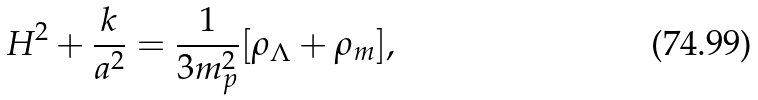Convert formula to latex. <formula><loc_0><loc_0><loc_500><loc_500>H ^ { 2 } + \frac { k } { a ^ { 2 } } = \frac { 1 } { 3 m _ { p } ^ { 2 } } [ \rho _ { \Lambda } + \rho _ { m } ] ,</formula> 